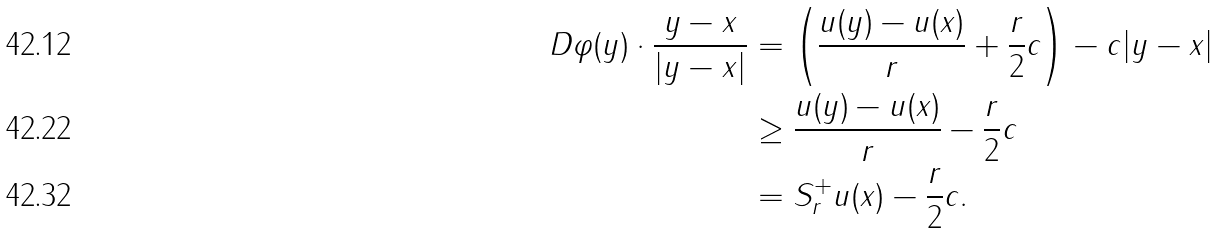<formula> <loc_0><loc_0><loc_500><loc_500>D \varphi ( y ) \cdot \frac { y - x } { | y - x | } & = \left ( \frac { u ( y ) - u ( x ) } { r } + \frac { r } { 2 } c \right ) - c | y - x | \\ & \geq \frac { u ( y ) - u ( x ) } { r } - \frac { r } { 2 } c \\ & = S ^ { + } _ { r } u ( x ) - \frac { r } { 2 } c .</formula> 